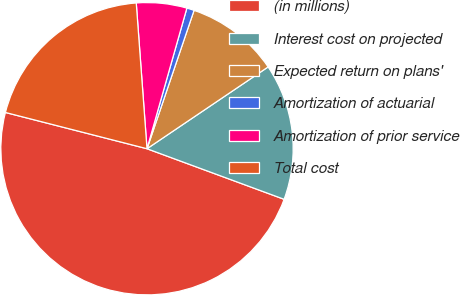Convert chart to OTSL. <chart><loc_0><loc_0><loc_500><loc_500><pie_chart><fcel>(in millions)<fcel>Interest cost on projected<fcel>Expected return on plans'<fcel>Amortization of actuarial<fcel>Amortization of prior service<fcel>Total cost<nl><fcel>48.37%<fcel>15.08%<fcel>10.33%<fcel>0.82%<fcel>5.57%<fcel>19.84%<nl></chart> 